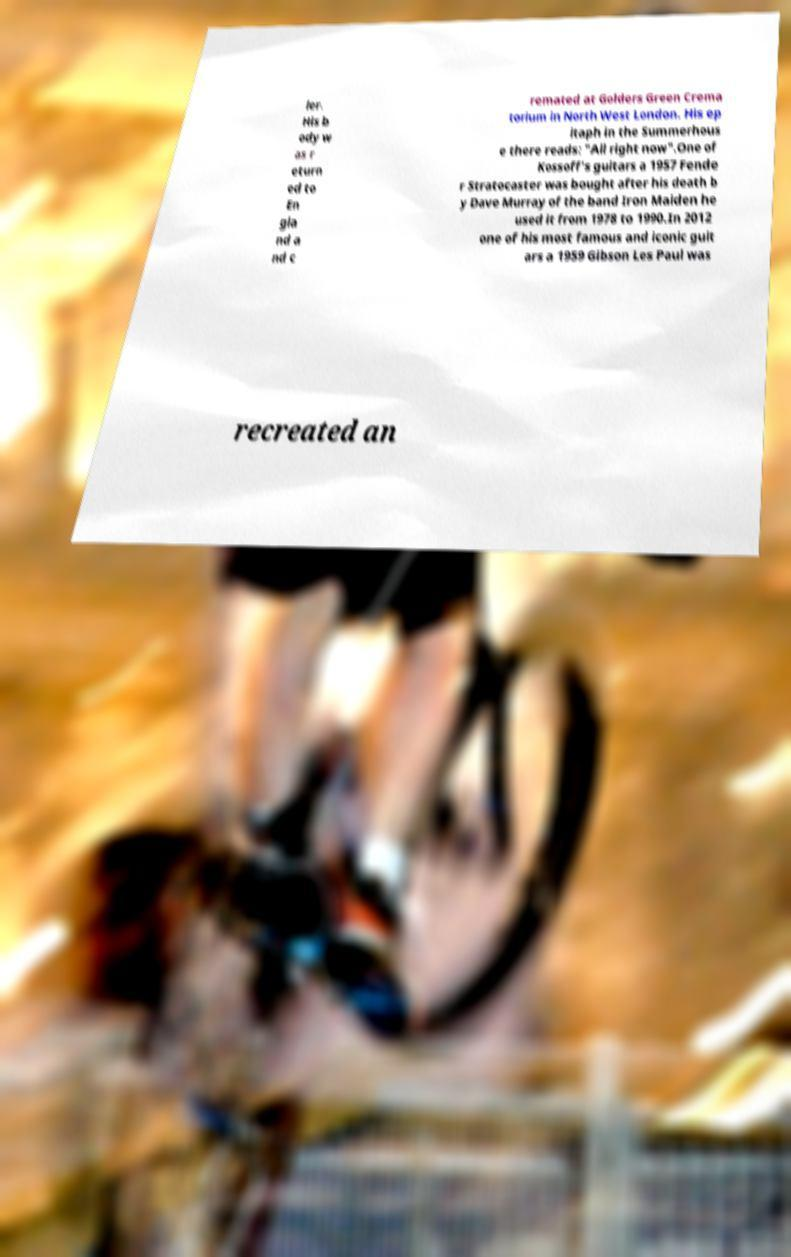Please read and relay the text visible in this image. What does it say? ler. His b ody w as r eturn ed to En gla nd a nd c remated at Golders Green Crema torium in North West London. His ep itaph in the Summerhous e there reads: "All right now".One of Kossoff's guitars a 1957 Fende r Stratocaster was bought after his death b y Dave Murray of the band Iron Maiden he used it from 1978 to 1990.In 2012 one of his most famous and iconic guit ars a 1959 Gibson Les Paul was recreated an 